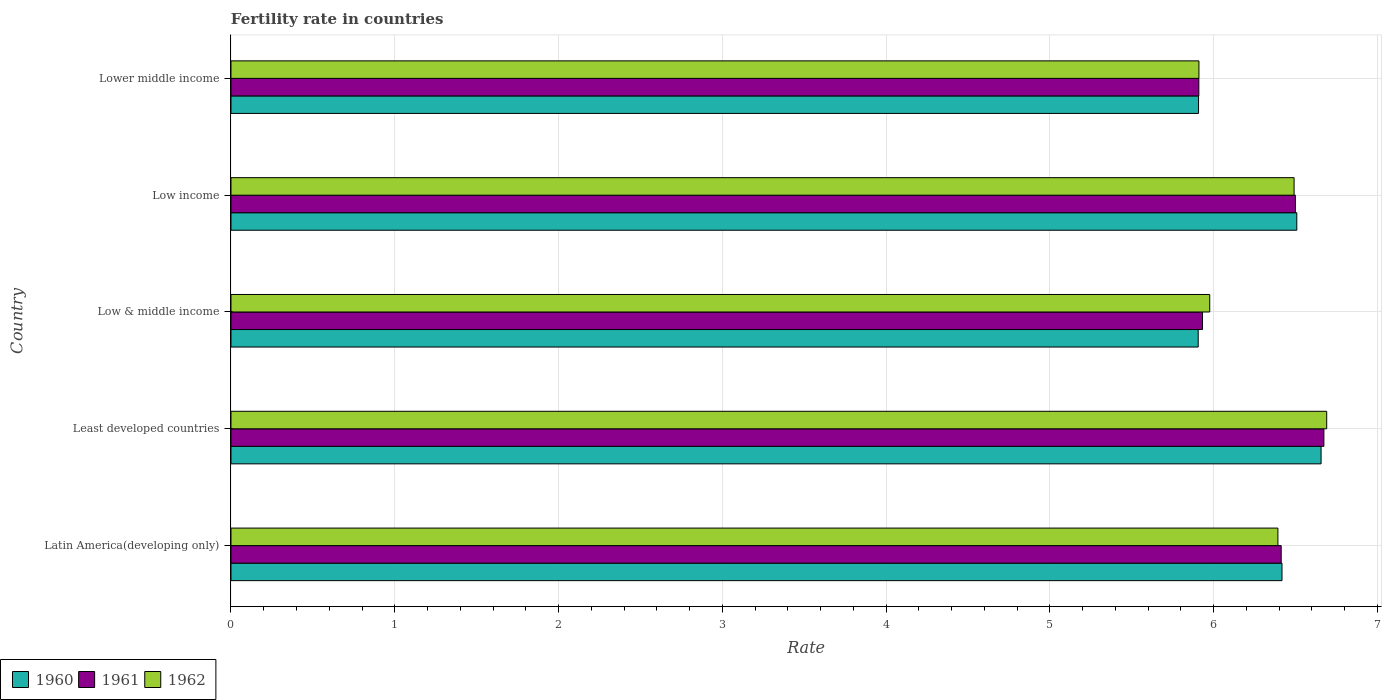Are the number of bars per tick equal to the number of legend labels?
Give a very brief answer. Yes. What is the label of the 3rd group of bars from the top?
Offer a very short reply. Low & middle income. What is the fertility rate in 1961 in Latin America(developing only)?
Your answer should be very brief. 6.41. Across all countries, what is the maximum fertility rate in 1960?
Offer a very short reply. 6.66. Across all countries, what is the minimum fertility rate in 1962?
Make the answer very short. 5.91. In which country was the fertility rate in 1962 maximum?
Provide a short and direct response. Least developed countries. What is the total fertility rate in 1961 in the graph?
Your answer should be compact. 31.43. What is the difference between the fertility rate in 1961 in Latin America(developing only) and that in Least developed countries?
Your answer should be very brief. -0.26. What is the difference between the fertility rate in 1962 in Lower middle income and the fertility rate in 1961 in Low & middle income?
Your response must be concise. -0.02. What is the average fertility rate in 1962 per country?
Your answer should be very brief. 6.29. What is the difference between the fertility rate in 1960 and fertility rate in 1962 in Latin America(developing only)?
Give a very brief answer. 0.03. What is the ratio of the fertility rate in 1961 in Least developed countries to that in Low income?
Offer a very short reply. 1.03. Is the difference between the fertility rate in 1960 in Latin America(developing only) and Low income greater than the difference between the fertility rate in 1962 in Latin America(developing only) and Low income?
Give a very brief answer. Yes. What is the difference between the highest and the second highest fertility rate in 1960?
Keep it short and to the point. 0.15. What is the difference between the highest and the lowest fertility rate in 1961?
Make the answer very short. 0.76. In how many countries, is the fertility rate in 1961 greater than the average fertility rate in 1961 taken over all countries?
Make the answer very short. 3. Is the sum of the fertility rate in 1961 in Least developed countries and Low & middle income greater than the maximum fertility rate in 1962 across all countries?
Your response must be concise. Yes. What does the 1st bar from the top in Low income represents?
Offer a very short reply. 1962. What does the 1st bar from the bottom in Low income represents?
Offer a very short reply. 1960. Is it the case that in every country, the sum of the fertility rate in 1961 and fertility rate in 1962 is greater than the fertility rate in 1960?
Offer a very short reply. Yes. How many bars are there?
Your response must be concise. 15. What is the difference between two consecutive major ticks on the X-axis?
Your answer should be compact. 1. Are the values on the major ticks of X-axis written in scientific E-notation?
Your answer should be very brief. No. Does the graph contain grids?
Give a very brief answer. Yes. Where does the legend appear in the graph?
Provide a succinct answer. Bottom left. How many legend labels are there?
Your response must be concise. 3. What is the title of the graph?
Provide a succinct answer. Fertility rate in countries. What is the label or title of the X-axis?
Offer a very short reply. Rate. What is the label or title of the Y-axis?
Offer a very short reply. Country. What is the Rate of 1960 in Latin America(developing only)?
Your answer should be very brief. 6.42. What is the Rate of 1961 in Latin America(developing only)?
Ensure brevity in your answer.  6.41. What is the Rate of 1962 in Latin America(developing only)?
Your answer should be very brief. 6.39. What is the Rate in 1960 in Least developed countries?
Provide a succinct answer. 6.66. What is the Rate in 1961 in Least developed countries?
Your answer should be compact. 6.67. What is the Rate of 1962 in Least developed countries?
Keep it short and to the point. 6.69. What is the Rate of 1960 in Low & middle income?
Make the answer very short. 5.91. What is the Rate of 1961 in Low & middle income?
Your response must be concise. 5.93. What is the Rate of 1962 in Low & middle income?
Give a very brief answer. 5.98. What is the Rate in 1960 in Low income?
Make the answer very short. 6.51. What is the Rate in 1961 in Low income?
Your answer should be compact. 6.5. What is the Rate of 1962 in Low income?
Make the answer very short. 6.49. What is the Rate in 1960 in Lower middle income?
Ensure brevity in your answer.  5.91. What is the Rate in 1961 in Lower middle income?
Your answer should be very brief. 5.91. What is the Rate in 1962 in Lower middle income?
Keep it short and to the point. 5.91. Across all countries, what is the maximum Rate in 1960?
Provide a succinct answer. 6.66. Across all countries, what is the maximum Rate of 1961?
Provide a succinct answer. 6.67. Across all countries, what is the maximum Rate in 1962?
Make the answer very short. 6.69. Across all countries, what is the minimum Rate in 1960?
Make the answer very short. 5.91. Across all countries, what is the minimum Rate of 1961?
Offer a terse response. 5.91. Across all countries, what is the minimum Rate in 1962?
Ensure brevity in your answer.  5.91. What is the total Rate of 1960 in the graph?
Provide a succinct answer. 31.4. What is the total Rate in 1961 in the graph?
Provide a succinct answer. 31.43. What is the total Rate of 1962 in the graph?
Offer a terse response. 31.46. What is the difference between the Rate in 1960 in Latin America(developing only) and that in Least developed countries?
Offer a very short reply. -0.24. What is the difference between the Rate in 1961 in Latin America(developing only) and that in Least developed countries?
Offer a very short reply. -0.26. What is the difference between the Rate in 1962 in Latin America(developing only) and that in Least developed countries?
Your answer should be very brief. -0.3. What is the difference between the Rate in 1960 in Latin America(developing only) and that in Low & middle income?
Offer a terse response. 0.51. What is the difference between the Rate in 1961 in Latin America(developing only) and that in Low & middle income?
Your answer should be compact. 0.48. What is the difference between the Rate of 1962 in Latin America(developing only) and that in Low & middle income?
Ensure brevity in your answer.  0.42. What is the difference between the Rate of 1960 in Latin America(developing only) and that in Low income?
Your answer should be compact. -0.09. What is the difference between the Rate in 1961 in Latin America(developing only) and that in Low income?
Offer a very short reply. -0.09. What is the difference between the Rate in 1962 in Latin America(developing only) and that in Low income?
Provide a short and direct response. -0.1. What is the difference between the Rate of 1960 in Latin America(developing only) and that in Lower middle income?
Your answer should be compact. 0.51. What is the difference between the Rate of 1961 in Latin America(developing only) and that in Lower middle income?
Provide a short and direct response. 0.5. What is the difference between the Rate of 1962 in Latin America(developing only) and that in Lower middle income?
Provide a succinct answer. 0.48. What is the difference between the Rate in 1960 in Least developed countries and that in Low & middle income?
Your response must be concise. 0.75. What is the difference between the Rate of 1961 in Least developed countries and that in Low & middle income?
Give a very brief answer. 0.74. What is the difference between the Rate of 1960 in Least developed countries and that in Low income?
Offer a terse response. 0.15. What is the difference between the Rate of 1961 in Least developed countries and that in Low income?
Provide a short and direct response. 0.17. What is the difference between the Rate of 1962 in Least developed countries and that in Low income?
Ensure brevity in your answer.  0.2. What is the difference between the Rate of 1960 in Least developed countries and that in Lower middle income?
Offer a terse response. 0.75. What is the difference between the Rate in 1961 in Least developed countries and that in Lower middle income?
Offer a terse response. 0.76. What is the difference between the Rate in 1962 in Least developed countries and that in Lower middle income?
Ensure brevity in your answer.  0.78. What is the difference between the Rate in 1960 in Low & middle income and that in Low income?
Your response must be concise. -0.6. What is the difference between the Rate in 1961 in Low & middle income and that in Low income?
Provide a short and direct response. -0.57. What is the difference between the Rate of 1962 in Low & middle income and that in Low income?
Your response must be concise. -0.52. What is the difference between the Rate in 1960 in Low & middle income and that in Lower middle income?
Offer a very short reply. -0. What is the difference between the Rate of 1961 in Low & middle income and that in Lower middle income?
Keep it short and to the point. 0.02. What is the difference between the Rate in 1962 in Low & middle income and that in Lower middle income?
Your answer should be compact. 0.07. What is the difference between the Rate of 1960 in Low income and that in Lower middle income?
Provide a short and direct response. 0.6. What is the difference between the Rate of 1961 in Low income and that in Lower middle income?
Ensure brevity in your answer.  0.59. What is the difference between the Rate in 1962 in Low income and that in Lower middle income?
Your answer should be very brief. 0.58. What is the difference between the Rate of 1960 in Latin America(developing only) and the Rate of 1961 in Least developed countries?
Ensure brevity in your answer.  -0.26. What is the difference between the Rate of 1960 in Latin America(developing only) and the Rate of 1962 in Least developed countries?
Provide a succinct answer. -0.27. What is the difference between the Rate in 1961 in Latin America(developing only) and the Rate in 1962 in Least developed countries?
Your answer should be compact. -0.28. What is the difference between the Rate of 1960 in Latin America(developing only) and the Rate of 1961 in Low & middle income?
Offer a very short reply. 0.49. What is the difference between the Rate of 1960 in Latin America(developing only) and the Rate of 1962 in Low & middle income?
Your response must be concise. 0.44. What is the difference between the Rate in 1961 in Latin America(developing only) and the Rate in 1962 in Low & middle income?
Give a very brief answer. 0.44. What is the difference between the Rate of 1960 in Latin America(developing only) and the Rate of 1961 in Low income?
Provide a short and direct response. -0.08. What is the difference between the Rate of 1960 in Latin America(developing only) and the Rate of 1962 in Low income?
Your answer should be very brief. -0.07. What is the difference between the Rate in 1961 in Latin America(developing only) and the Rate in 1962 in Low income?
Provide a succinct answer. -0.08. What is the difference between the Rate in 1960 in Latin America(developing only) and the Rate in 1961 in Lower middle income?
Give a very brief answer. 0.51. What is the difference between the Rate in 1960 in Latin America(developing only) and the Rate in 1962 in Lower middle income?
Provide a short and direct response. 0.51. What is the difference between the Rate in 1961 in Latin America(developing only) and the Rate in 1962 in Lower middle income?
Keep it short and to the point. 0.5. What is the difference between the Rate in 1960 in Least developed countries and the Rate in 1961 in Low & middle income?
Provide a succinct answer. 0.72. What is the difference between the Rate in 1960 in Least developed countries and the Rate in 1962 in Low & middle income?
Your answer should be compact. 0.68. What is the difference between the Rate of 1961 in Least developed countries and the Rate of 1962 in Low & middle income?
Make the answer very short. 0.7. What is the difference between the Rate of 1960 in Least developed countries and the Rate of 1961 in Low income?
Offer a very short reply. 0.16. What is the difference between the Rate of 1960 in Least developed countries and the Rate of 1962 in Low income?
Ensure brevity in your answer.  0.16. What is the difference between the Rate in 1961 in Least developed countries and the Rate in 1962 in Low income?
Give a very brief answer. 0.18. What is the difference between the Rate in 1960 in Least developed countries and the Rate in 1961 in Lower middle income?
Keep it short and to the point. 0.75. What is the difference between the Rate of 1960 in Least developed countries and the Rate of 1962 in Lower middle income?
Give a very brief answer. 0.75. What is the difference between the Rate of 1961 in Least developed countries and the Rate of 1962 in Lower middle income?
Make the answer very short. 0.76. What is the difference between the Rate in 1960 in Low & middle income and the Rate in 1961 in Low income?
Keep it short and to the point. -0.59. What is the difference between the Rate in 1960 in Low & middle income and the Rate in 1962 in Low income?
Offer a terse response. -0.59. What is the difference between the Rate of 1961 in Low & middle income and the Rate of 1962 in Low income?
Give a very brief answer. -0.56. What is the difference between the Rate of 1960 in Low & middle income and the Rate of 1961 in Lower middle income?
Your answer should be very brief. -0. What is the difference between the Rate in 1960 in Low & middle income and the Rate in 1962 in Lower middle income?
Offer a terse response. -0. What is the difference between the Rate of 1961 in Low & middle income and the Rate of 1962 in Lower middle income?
Your response must be concise. 0.02. What is the difference between the Rate of 1960 in Low income and the Rate of 1961 in Lower middle income?
Ensure brevity in your answer.  0.6. What is the difference between the Rate of 1960 in Low income and the Rate of 1962 in Lower middle income?
Provide a succinct answer. 0.6. What is the difference between the Rate in 1961 in Low income and the Rate in 1962 in Lower middle income?
Keep it short and to the point. 0.59. What is the average Rate in 1960 per country?
Provide a succinct answer. 6.28. What is the average Rate in 1961 per country?
Provide a short and direct response. 6.29. What is the average Rate in 1962 per country?
Your answer should be very brief. 6.29. What is the difference between the Rate of 1960 and Rate of 1961 in Latin America(developing only)?
Offer a terse response. 0.01. What is the difference between the Rate of 1960 and Rate of 1962 in Latin America(developing only)?
Ensure brevity in your answer.  0.03. What is the difference between the Rate of 1961 and Rate of 1962 in Latin America(developing only)?
Provide a short and direct response. 0.02. What is the difference between the Rate in 1960 and Rate in 1961 in Least developed countries?
Your response must be concise. -0.02. What is the difference between the Rate of 1960 and Rate of 1962 in Least developed countries?
Make the answer very short. -0.03. What is the difference between the Rate in 1961 and Rate in 1962 in Least developed countries?
Your answer should be very brief. -0.02. What is the difference between the Rate in 1960 and Rate in 1961 in Low & middle income?
Give a very brief answer. -0.03. What is the difference between the Rate in 1960 and Rate in 1962 in Low & middle income?
Your response must be concise. -0.07. What is the difference between the Rate of 1961 and Rate of 1962 in Low & middle income?
Provide a succinct answer. -0.04. What is the difference between the Rate in 1960 and Rate in 1961 in Low income?
Give a very brief answer. 0.01. What is the difference between the Rate in 1960 and Rate in 1962 in Low income?
Your answer should be compact. 0.02. What is the difference between the Rate of 1961 and Rate of 1962 in Low income?
Your answer should be very brief. 0.01. What is the difference between the Rate in 1960 and Rate in 1961 in Lower middle income?
Your answer should be very brief. -0. What is the difference between the Rate of 1960 and Rate of 1962 in Lower middle income?
Make the answer very short. -0. What is the difference between the Rate in 1961 and Rate in 1962 in Lower middle income?
Make the answer very short. -0. What is the ratio of the Rate of 1960 in Latin America(developing only) to that in Least developed countries?
Ensure brevity in your answer.  0.96. What is the ratio of the Rate in 1961 in Latin America(developing only) to that in Least developed countries?
Your answer should be very brief. 0.96. What is the ratio of the Rate in 1962 in Latin America(developing only) to that in Least developed countries?
Ensure brevity in your answer.  0.96. What is the ratio of the Rate in 1960 in Latin America(developing only) to that in Low & middle income?
Provide a succinct answer. 1.09. What is the ratio of the Rate in 1961 in Latin America(developing only) to that in Low & middle income?
Offer a very short reply. 1.08. What is the ratio of the Rate of 1962 in Latin America(developing only) to that in Low & middle income?
Offer a very short reply. 1.07. What is the ratio of the Rate of 1960 in Latin America(developing only) to that in Low income?
Your answer should be very brief. 0.99. What is the ratio of the Rate in 1961 in Latin America(developing only) to that in Low income?
Keep it short and to the point. 0.99. What is the ratio of the Rate of 1960 in Latin America(developing only) to that in Lower middle income?
Your answer should be compact. 1.09. What is the ratio of the Rate in 1961 in Latin America(developing only) to that in Lower middle income?
Offer a very short reply. 1.09. What is the ratio of the Rate of 1962 in Latin America(developing only) to that in Lower middle income?
Ensure brevity in your answer.  1.08. What is the ratio of the Rate in 1960 in Least developed countries to that in Low & middle income?
Your response must be concise. 1.13. What is the ratio of the Rate of 1961 in Least developed countries to that in Low & middle income?
Ensure brevity in your answer.  1.12. What is the ratio of the Rate in 1962 in Least developed countries to that in Low & middle income?
Make the answer very short. 1.12. What is the ratio of the Rate of 1960 in Least developed countries to that in Low income?
Offer a terse response. 1.02. What is the ratio of the Rate in 1961 in Least developed countries to that in Low income?
Provide a succinct answer. 1.03. What is the ratio of the Rate in 1962 in Least developed countries to that in Low income?
Give a very brief answer. 1.03. What is the ratio of the Rate in 1960 in Least developed countries to that in Lower middle income?
Your answer should be compact. 1.13. What is the ratio of the Rate in 1961 in Least developed countries to that in Lower middle income?
Your answer should be very brief. 1.13. What is the ratio of the Rate of 1962 in Least developed countries to that in Lower middle income?
Your response must be concise. 1.13. What is the ratio of the Rate of 1960 in Low & middle income to that in Low income?
Your response must be concise. 0.91. What is the ratio of the Rate in 1961 in Low & middle income to that in Low income?
Offer a very short reply. 0.91. What is the ratio of the Rate of 1962 in Low & middle income to that in Low income?
Offer a terse response. 0.92. What is the ratio of the Rate of 1961 in Low & middle income to that in Lower middle income?
Your answer should be compact. 1. What is the ratio of the Rate of 1962 in Low & middle income to that in Lower middle income?
Make the answer very short. 1.01. What is the ratio of the Rate in 1960 in Low income to that in Lower middle income?
Provide a short and direct response. 1.1. What is the ratio of the Rate in 1961 in Low income to that in Lower middle income?
Ensure brevity in your answer.  1.1. What is the ratio of the Rate in 1962 in Low income to that in Lower middle income?
Make the answer very short. 1.1. What is the difference between the highest and the second highest Rate of 1960?
Offer a terse response. 0.15. What is the difference between the highest and the second highest Rate in 1961?
Provide a short and direct response. 0.17. What is the difference between the highest and the second highest Rate in 1962?
Ensure brevity in your answer.  0.2. What is the difference between the highest and the lowest Rate of 1960?
Provide a succinct answer. 0.75. What is the difference between the highest and the lowest Rate in 1961?
Offer a very short reply. 0.76. What is the difference between the highest and the lowest Rate in 1962?
Ensure brevity in your answer.  0.78. 